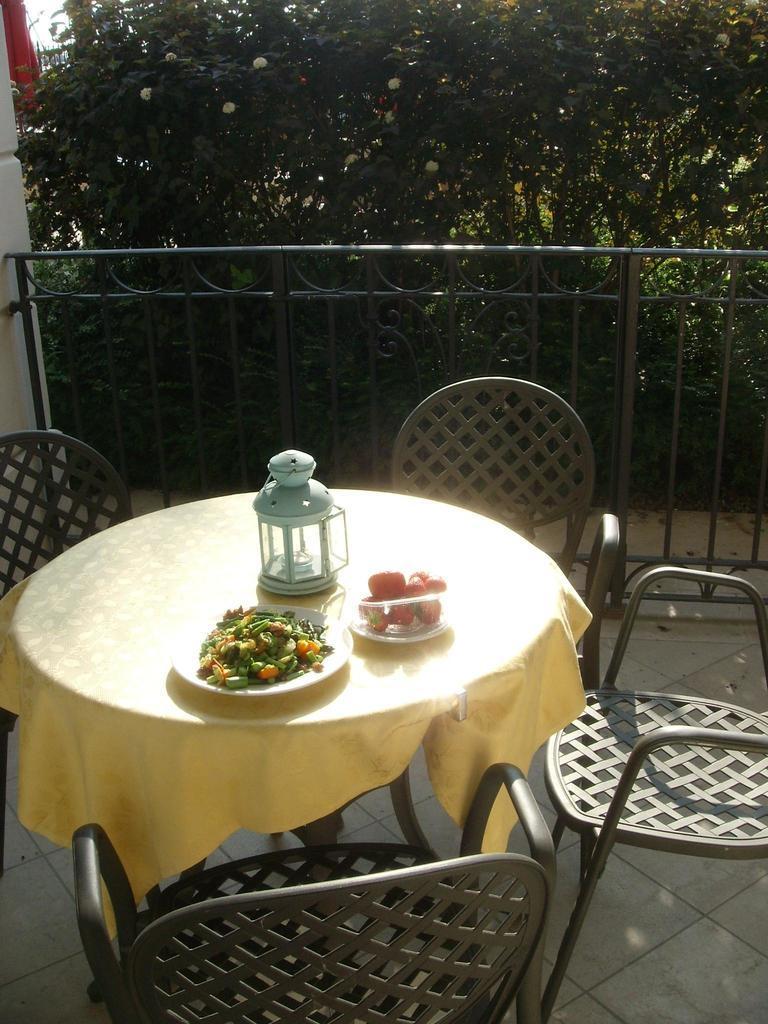Please provide a concise description of this image. In the center of the image there is a table on which there are objects. There are chairs. In the background of the image there are trees. There is a fencing. 